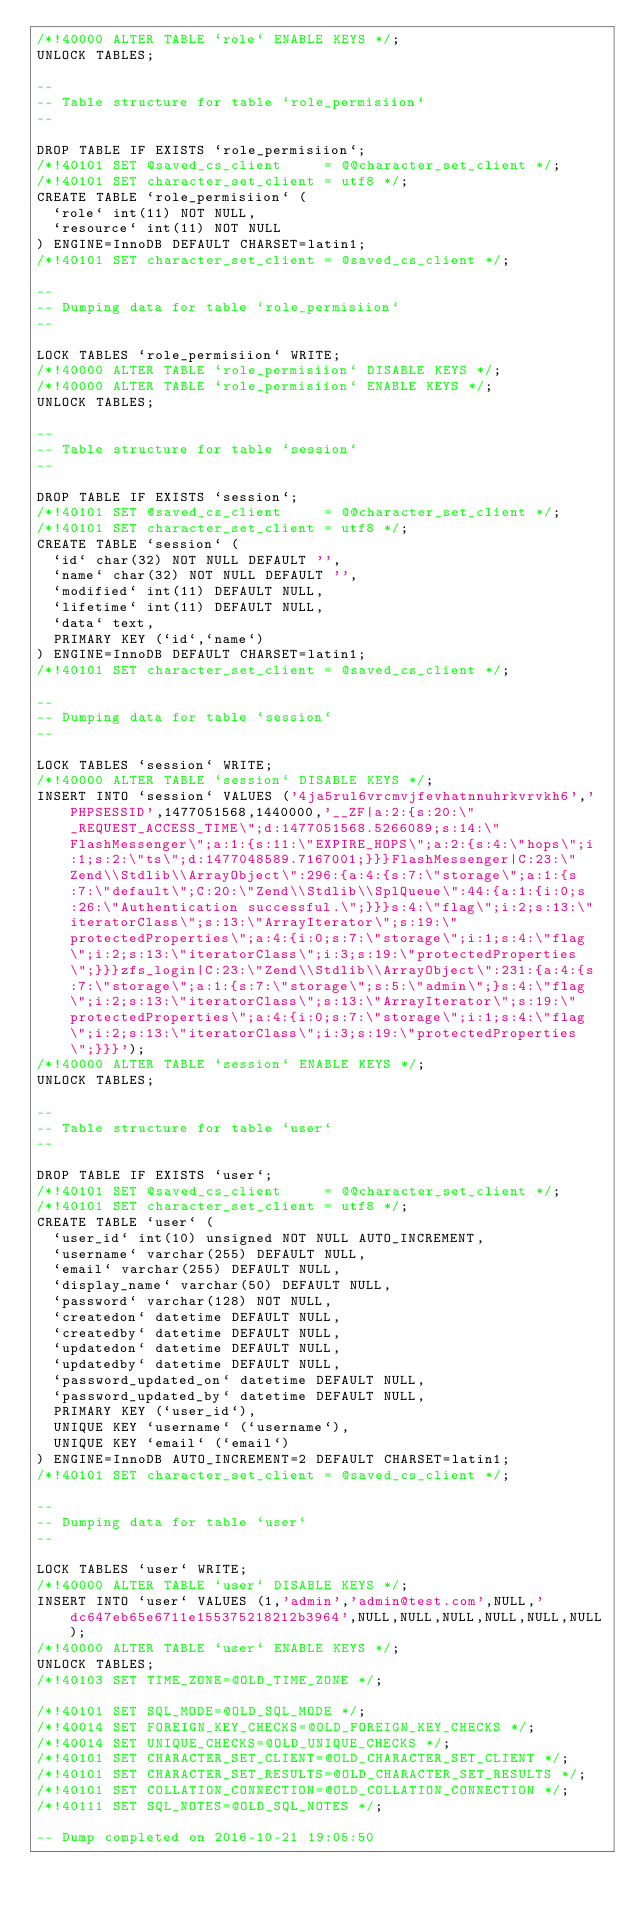<code> <loc_0><loc_0><loc_500><loc_500><_SQL_>/*!40000 ALTER TABLE `role` ENABLE KEYS */;
UNLOCK TABLES;

--
-- Table structure for table `role_permisiion`
--

DROP TABLE IF EXISTS `role_permisiion`;
/*!40101 SET @saved_cs_client     = @@character_set_client */;
/*!40101 SET character_set_client = utf8 */;
CREATE TABLE `role_permisiion` (
  `role` int(11) NOT NULL,
  `resource` int(11) NOT NULL
) ENGINE=InnoDB DEFAULT CHARSET=latin1;
/*!40101 SET character_set_client = @saved_cs_client */;

--
-- Dumping data for table `role_permisiion`
--

LOCK TABLES `role_permisiion` WRITE;
/*!40000 ALTER TABLE `role_permisiion` DISABLE KEYS */;
/*!40000 ALTER TABLE `role_permisiion` ENABLE KEYS */;
UNLOCK TABLES;

--
-- Table structure for table `session`
--

DROP TABLE IF EXISTS `session`;
/*!40101 SET @saved_cs_client     = @@character_set_client */;
/*!40101 SET character_set_client = utf8 */;
CREATE TABLE `session` (
  `id` char(32) NOT NULL DEFAULT '',
  `name` char(32) NOT NULL DEFAULT '',
  `modified` int(11) DEFAULT NULL,
  `lifetime` int(11) DEFAULT NULL,
  `data` text,
  PRIMARY KEY (`id`,`name`)
) ENGINE=InnoDB DEFAULT CHARSET=latin1;
/*!40101 SET character_set_client = @saved_cs_client */;

--
-- Dumping data for table `session`
--

LOCK TABLES `session` WRITE;
/*!40000 ALTER TABLE `session` DISABLE KEYS */;
INSERT INTO `session` VALUES ('4ja5rul6vrcmvjfevhatnnuhrkvrvkh6','PHPSESSID',1477051568,1440000,'__ZF|a:2:{s:20:\"_REQUEST_ACCESS_TIME\";d:1477051568.5266089;s:14:\"FlashMessenger\";a:1:{s:11:\"EXPIRE_HOPS\";a:2:{s:4:\"hops\";i:1;s:2:\"ts\";d:1477048589.7167001;}}}FlashMessenger|C:23:\"Zend\\Stdlib\\ArrayObject\":296:{a:4:{s:7:\"storage\";a:1:{s:7:\"default\";C:20:\"Zend\\Stdlib\\SplQueue\":44:{a:1:{i:0;s:26:\"Authentication successful.\";}}}s:4:\"flag\";i:2;s:13:\"iteratorClass\";s:13:\"ArrayIterator\";s:19:\"protectedProperties\";a:4:{i:0;s:7:\"storage\";i:1;s:4:\"flag\";i:2;s:13:\"iteratorClass\";i:3;s:19:\"protectedProperties\";}}}zfs_login|C:23:\"Zend\\Stdlib\\ArrayObject\":231:{a:4:{s:7:\"storage\";a:1:{s:7:\"storage\";s:5:\"admin\";}s:4:\"flag\";i:2;s:13:\"iteratorClass\";s:13:\"ArrayIterator\";s:19:\"protectedProperties\";a:4:{i:0;s:7:\"storage\";i:1;s:4:\"flag\";i:2;s:13:\"iteratorClass\";i:3;s:19:\"protectedProperties\";}}}');
/*!40000 ALTER TABLE `session` ENABLE KEYS */;
UNLOCK TABLES;

--
-- Table structure for table `user`
--

DROP TABLE IF EXISTS `user`;
/*!40101 SET @saved_cs_client     = @@character_set_client */;
/*!40101 SET character_set_client = utf8 */;
CREATE TABLE `user` (
  `user_id` int(10) unsigned NOT NULL AUTO_INCREMENT,
  `username` varchar(255) DEFAULT NULL,
  `email` varchar(255) DEFAULT NULL,
  `display_name` varchar(50) DEFAULT NULL,
  `password` varchar(128) NOT NULL,
  `createdon` datetime DEFAULT NULL,
  `createdby` datetime DEFAULT NULL,
  `updatedon` datetime DEFAULT NULL,
  `updatedby` datetime DEFAULT NULL,
  `password_updated_on` datetime DEFAULT NULL,
  `password_updated_by` datetime DEFAULT NULL,
  PRIMARY KEY (`user_id`),
  UNIQUE KEY `username` (`username`),
  UNIQUE KEY `email` (`email`)
) ENGINE=InnoDB AUTO_INCREMENT=2 DEFAULT CHARSET=latin1;
/*!40101 SET character_set_client = @saved_cs_client */;

--
-- Dumping data for table `user`
--

LOCK TABLES `user` WRITE;
/*!40000 ALTER TABLE `user` DISABLE KEYS */;
INSERT INTO `user` VALUES (1,'admin','admin@test.com',NULL,'dc647eb65e6711e155375218212b3964',NULL,NULL,NULL,NULL,NULL,NULL);
/*!40000 ALTER TABLE `user` ENABLE KEYS */;
UNLOCK TABLES;
/*!40103 SET TIME_ZONE=@OLD_TIME_ZONE */;

/*!40101 SET SQL_MODE=@OLD_SQL_MODE */;
/*!40014 SET FOREIGN_KEY_CHECKS=@OLD_FOREIGN_KEY_CHECKS */;
/*!40014 SET UNIQUE_CHECKS=@OLD_UNIQUE_CHECKS */;
/*!40101 SET CHARACTER_SET_CLIENT=@OLD_CHARACTER_SET_CLIENT */;
/*!40101 SET CHARACTER_SET_RESULTS=@OLD_CHARACTER_SET_RESULTS */;
/*!40101 SET COLLATION_CONNECTION=@OLD_COLLATION_CONNECTION */;
/*!40111 SET SQL_NOTES=@OLD_SQL_NOTES */;

-- Dump completed on 2016-10-21 19:05:50
</code> 